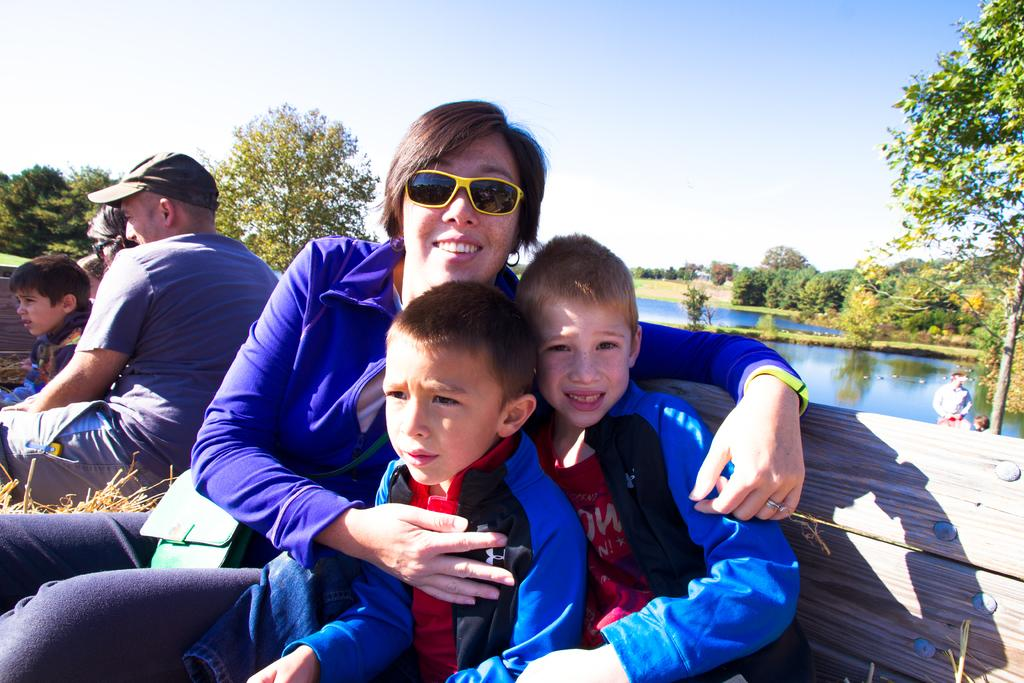What type of natural elements can be seen in the image? There are trees and water visible in the image. What are the people in the image doing? The people in the image are sitting on benches. What is visible at the top of the image? The sky is visible at the top of the image. What type of science experiment can be seen taking place in the image? There is no science experiment present in the image; it features a scene with trees, water, and people sitting on benches. Is there a volcano visible in the image? No, there is no volcano present in the image. 